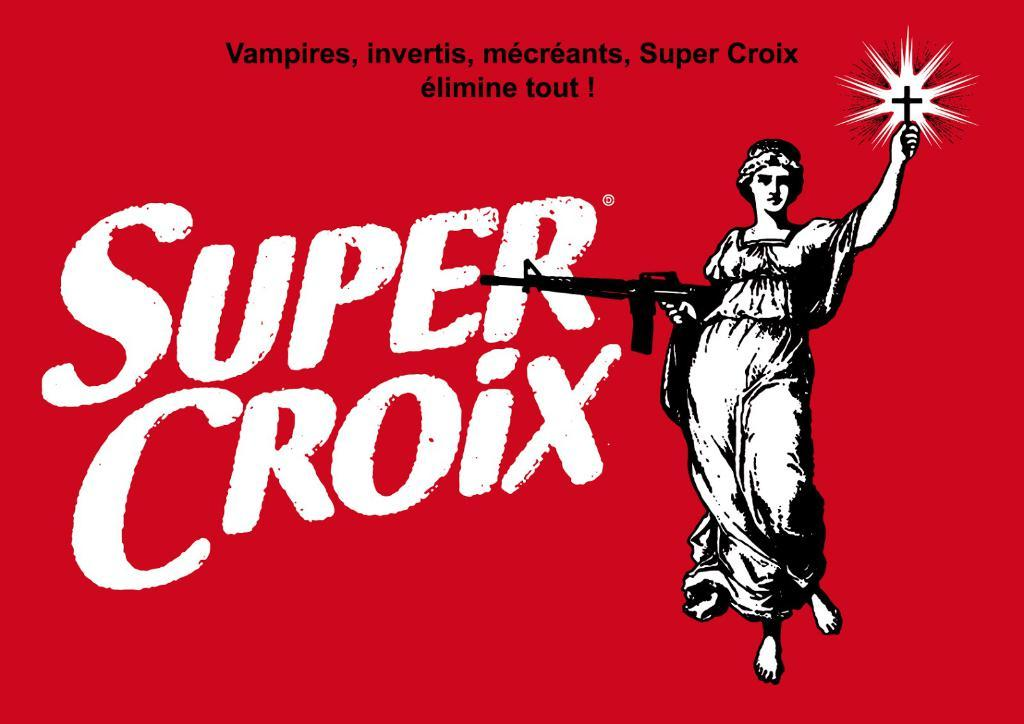<image>
Summarize the visual content of the image. super crios advertises vampires invertis and mecreants on a red background 